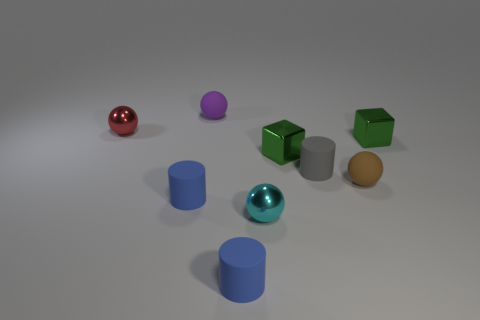Subtract all tiny gray matte cylinders. How many cylinders are left? 2 Subtract all cyan balls. How many balls are left? 3 Subtract 2 spheres. How many spheres are left? 2 Subtract all blue cubes. Subtract all red cylinders. How many cubes are left? 2 Subtract 1 purple balls. How many objects are left? 8 Subtract all cubes. How many objects are left? 7 Subtract all red balls. How many blue cylinders are left? 2 Subtract all purple things. Subtract all small metal cubes. How many objects are left? 6 Add 4 cylinders. How many cylinders are left? 7 Add 1 cyan metal things. How many cyan metal things exist? 2 